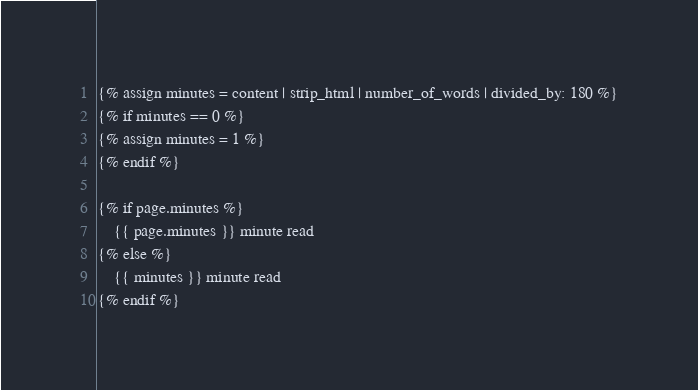<code> <loc_0><loc_0><loc_500><loc_500><_HTML_>{% assign minutes = content | strip_html | number_of_words | divided_by: 180 %}
{% if minutes == 0 %}
{% assign minutes = 1 %}
{% endif %}

{% if page.minutes %}
    {{ page.minutes }} minute read
{% else %}
    {{ minutes }} minute read
{% endif %}
</code> 